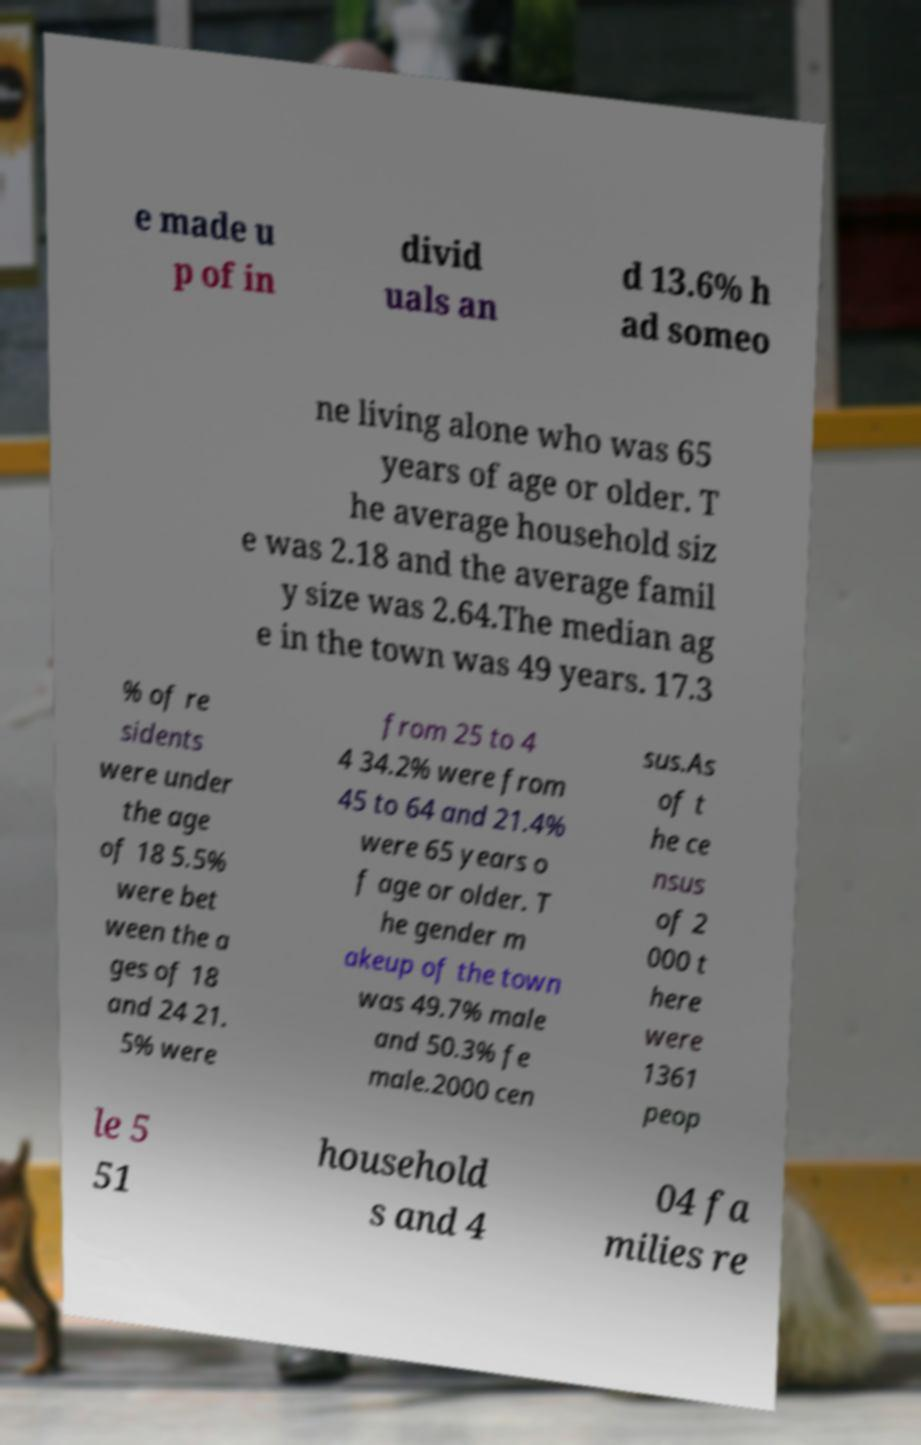Please read and relay the text visible in this image. What does it say? e made u p of in divid uals an d 13.6% h ad someo ne living alone who was 65 years of age or older. T he average household siz e was 2.18 and the average famil y size was 2.64.The median ag e in the town was 49 years. 17.3 % of re sidents were under the age of 18 5.5% were bet ween the a ges of 18 and 24 21. 5% were from 25 to 4 4 34.2% were from 45 to 64 and 21.4% were 65 years o f age or older. T he gender m akeup of the town was 49.7% male and 50.3% fe male.2000 cen sus.As of t he ce nsus of 2 000 t here were 1361 peop le 5 51 household s and 4 04 fa milies re 